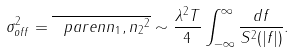<formula> <loc_0><loc_0><loc_500><loc_500>\sigma ^ { 2 } _ { o f f } = \overline { \ p a r e n { n _ { 1 } , n _ { 2 } } ^ { 2 } } \sim \frac { \lambda ^ { 2 } T } { 4 } \int _ { - \infty } ^ { \infty } \frac { d f } { S ^ { 2 } ( | f | ) } .</formula> 